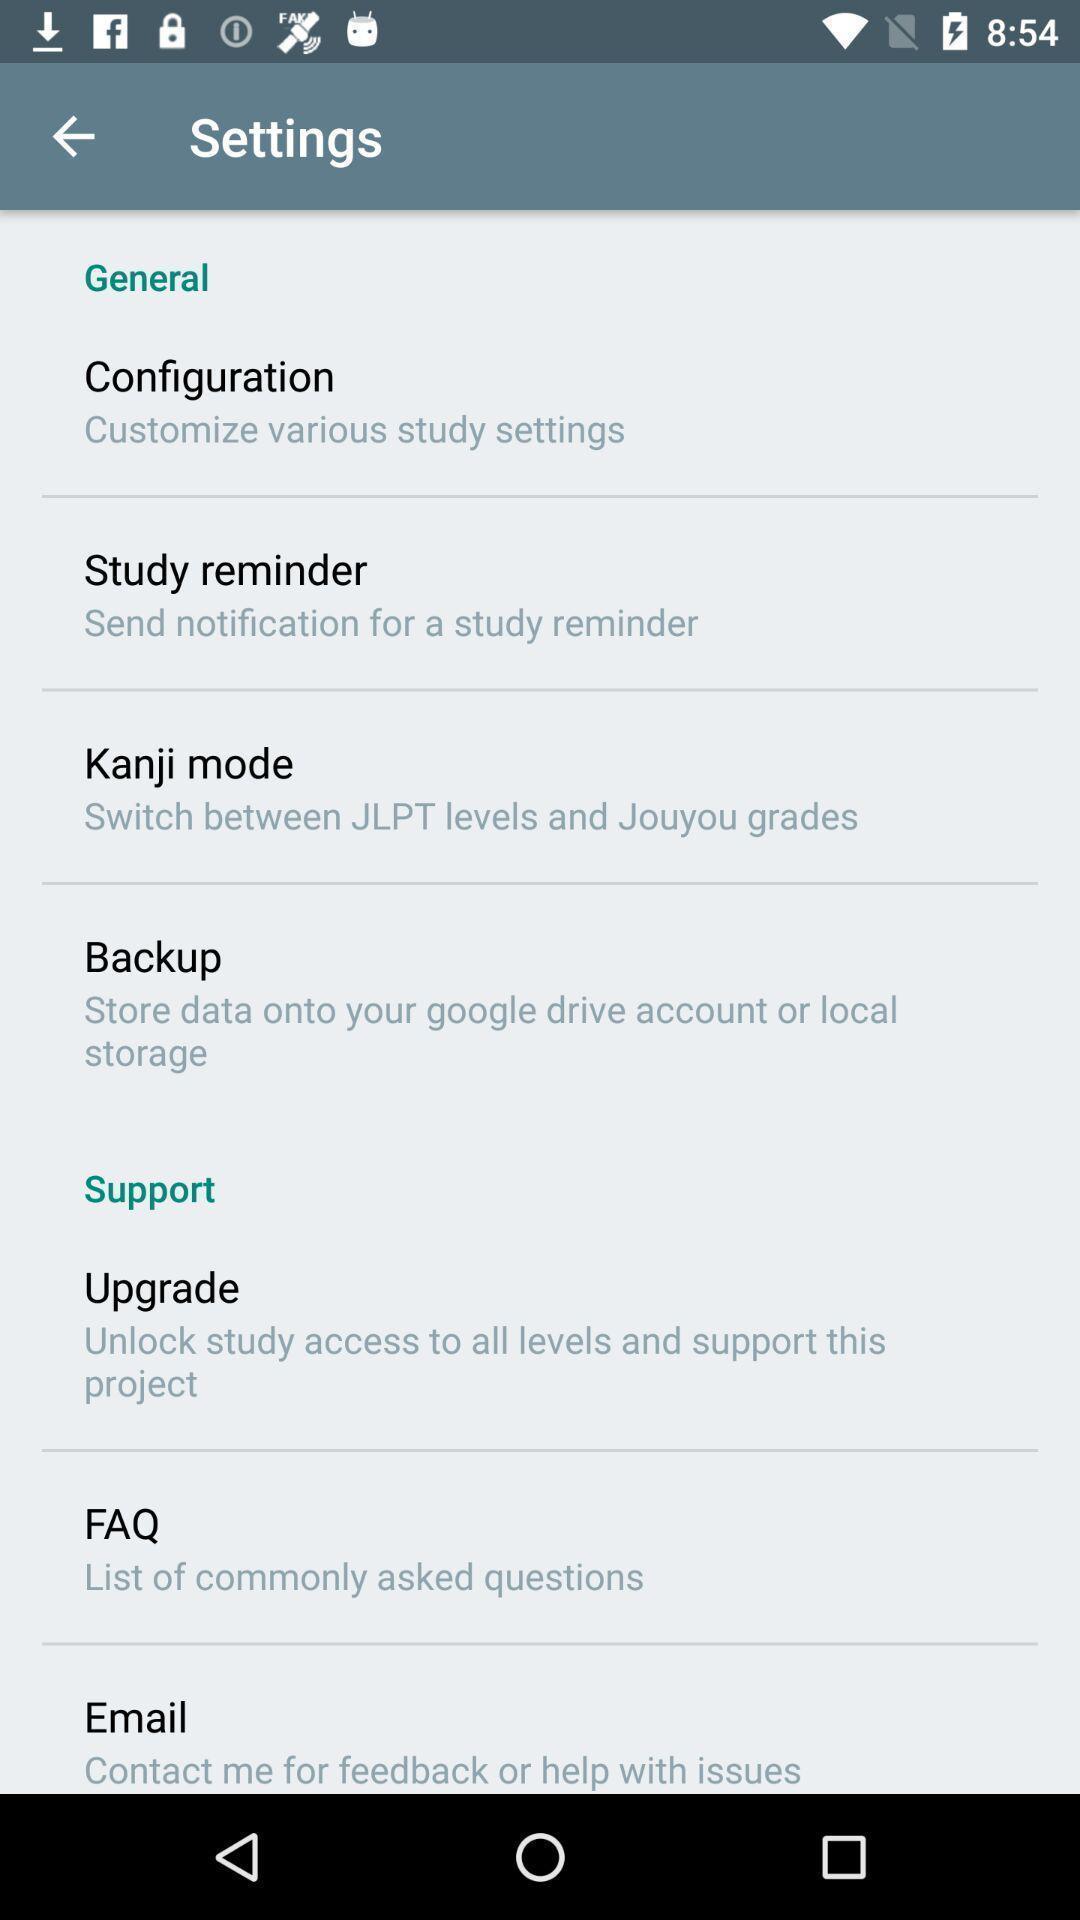What is the overall content of this screenshot? Settings page with multiple options. 